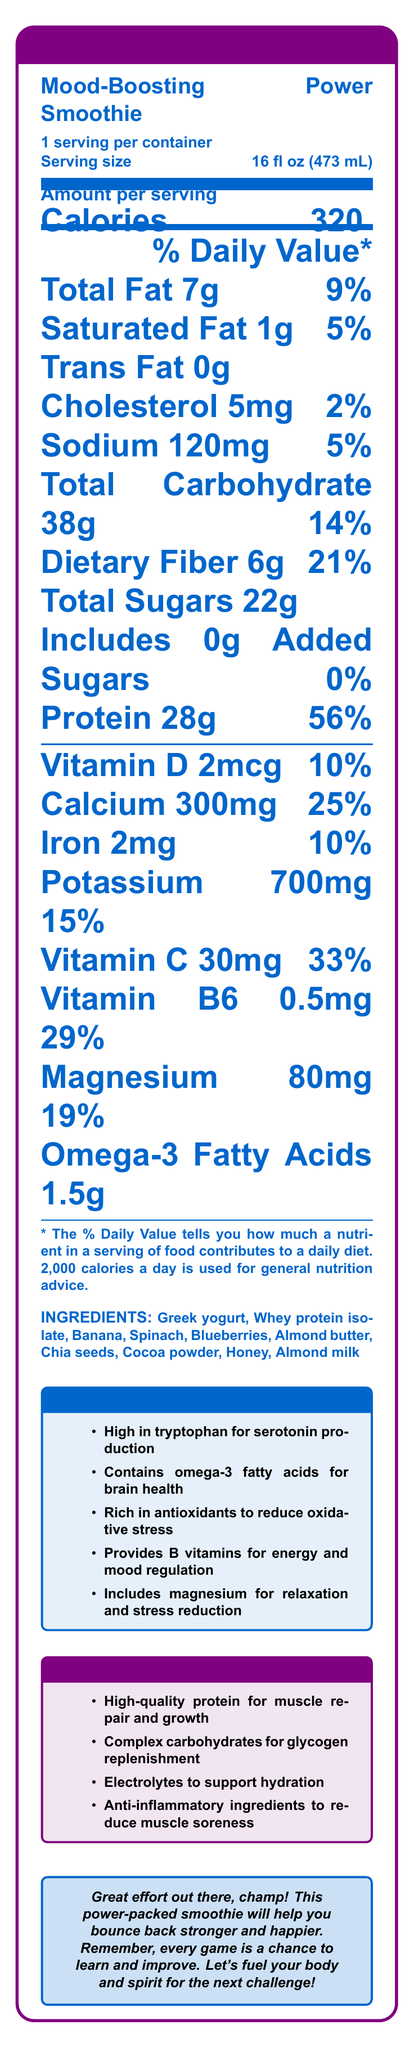What is the serving size for the Mood-Boosting Power Smoothie? The serving size is listed right under the product name on the nutrition facts label as 16 fl oz (473 mL).
Answer: 16 fl oz (473 mL) How many calories does one serving of the smoothie contain? The calorie content per serving is prominently displayed in bold as 320 calories.
Answer: 320 What percentage of the daily value of dietary fiber is in one serving? The daily value percentage for dietary fiber is listed as 21% next to its quantity of 6g.
Answer: 21% How much protein is in one serving of the smoothie? The amount of protein per serving is specified as 28g, with a daily value percentage of 56%.
Answer: 28g Does the smoothie contain any trans fat? The trans fat content is listed as 0g, indicating that there is no trans fat in the smoothie.
Answer: No For which nutrient does the smoothie provide the highest percent daily value? The smoothie provides the highest percent daily value for protein at 56%.
Answer: Protein Which nutrient is provided by the smoothie at 33% of the daily value? A. Vitamin D B. Calcium C. Vitamin C D. Iron Vitamin C is provided at 33% of the daily value, as indicated in the list of vitamins and minerals.
Answer: C. Vitamin C What is one of the key benefits of the smoothie for mood-boosting? A. Provides B vitamins for energy B. High levels of trans fat C. Low-calorie content D. Contains caffeine One of the mood-boosting benefits listed is that it provides B vitamins for energy and mood regulation.
Answer: A. Provides B vitamins for energy Does the smoothie contain added sugars? The nutrition label specifies that there are 0g of added sugars in the smoothie.
Answer: No Describe the main idea of the document. The document summarizes the nutritional values, ingredients, and specific health benefits associated with the smoothie, aiming to promote post-workout recovery and mood enhancement.
Answer: The document details the nutritional content and benefits of the "Mood-Boosting Power Smoothie," highlighting its high protein content for post-workout recovery and mood-boosting ingredients such as B vitamins and omega-3 fatty acids. It includes a supportive message to encourage the consumer. What types of fat does the smoothie contain? The document lists Total fat (7g) and breaks it down into Saturated fat (1g), indicating the presence of these types of fat.
Answer: Total fat and Saturated fat How much calcium is in one serving of the smoothie? The calcium content per serving is listed as 300mg with a daily value of 25%.
Answer: 300mg Is there any information about the price of the smoothie? The document contains nutritional information and benefits but does not mention the price.
Answer: Not enough information What ingredients are used in making the smoothie? The ingredients are listed explicitly at the bottom of the document.
Answer: Greek yogurt, Whey protein isolate, Banana, Spinach, Blueberries, Almond butter, Chia seeds, Cocoa powder, Honey, Almond milk Does the document include a supportive message? The document concludes with a supportive message encouraging the consumer, complimenting their effort, and mentioning the benefits of the smoothie for recovery and mood.
Answer: Yes 